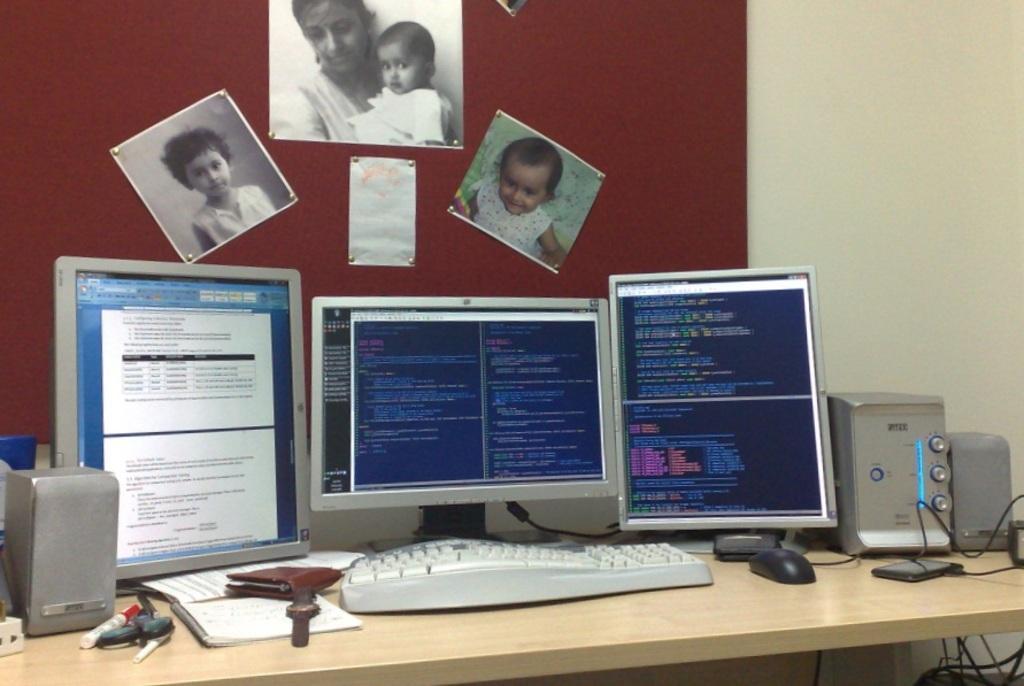In one or two sentences, can you explain what this image depicts? This is a table on which there are 3 monitors,keyboard,speakers,mouse,marker,etc. On the wall we can see 3 photographs and a paper. 